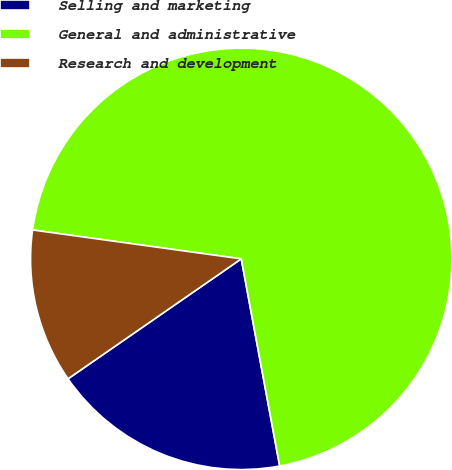Convert chart. <chart><loc_0><loc_0><loc_500><loc_500><pie_chart><fcel>Selling and marketing<fcel>General and administrative<fcel>Research and development<nl><fcel>18.28%<fcel>69.89%<fcel>11.83%<nl></chart> 